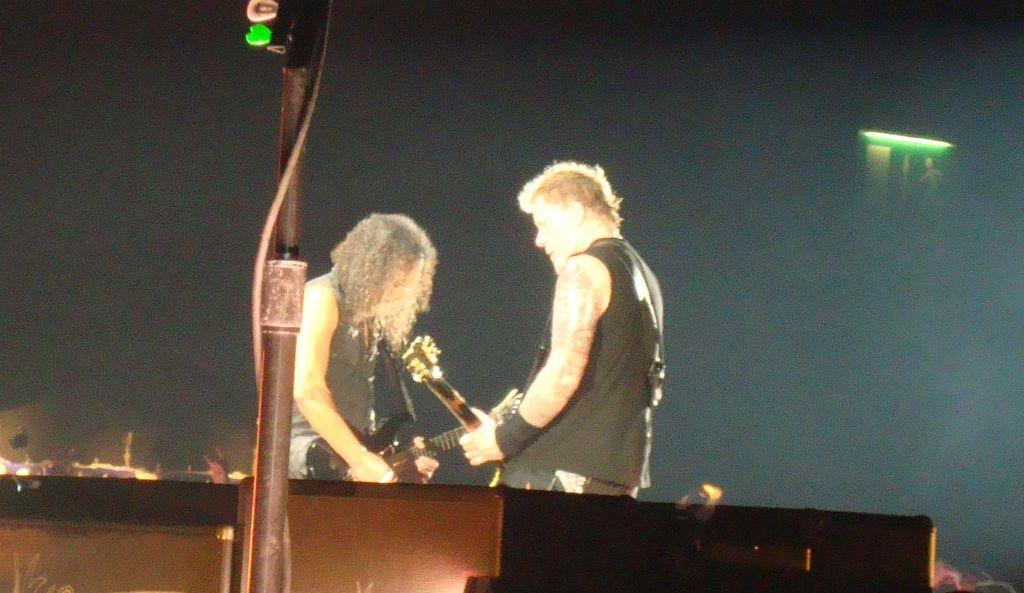Please provide a concise description of this image. This picture shows two men standing and playing guitar on the dais 